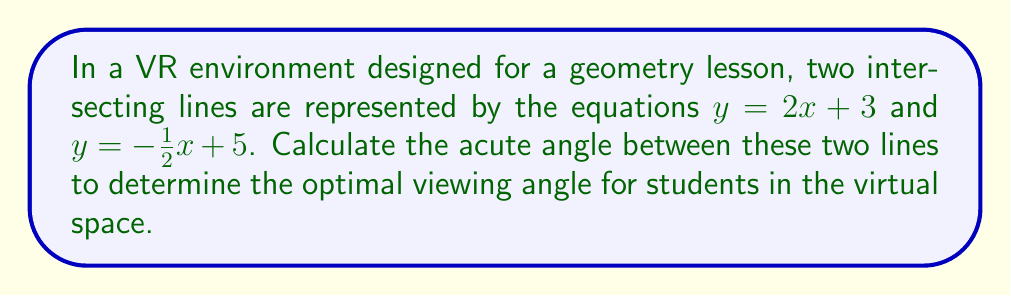What is the answer to this math problem? To find the angle between two intersecting lines in a VR environment, we can use the following steps:

1. Calculate the slopes of both lines:
   Line 1: $y = 2x + 3$, so $m_1 = 2$
   Line 2: $y = -\frac{1}{2}x + 5$, so $m_2 = -\frac{1}{2}$

2. Use the formula for the angle between two lines:
   $$\tan \theta = \left|\frac{m_1 - m_2}{1 + m_1m_2}\right|$$

3. Substitute the slopes into the formula:
   $$\tan \theta = \left|\frac{2 - (-\frac{1}{2})}{1 + 2(-\frac{1}{2})}\right| = \left|\frac{2 + \frac{1}{2}}{1 - 1}\right| = \left|\frac{\frac{5}{2}}{0}\right|$$

4. Simplify:
   $$\tan \theta = \frac{5}{2} = 2.5$$

5. To find $\theta$, we need to use the inverse tangent function:
   $$\theta = \arctan(2.5)$$

6. Using a calculator or computer, we can find:
   $$\theta \approx 1.1903 \text{ radians}$$

7. Convert radians to degrees:
   $$\theta \approx 1.1903 \times \frac{180}{\pi} \approx 68.20°$$

Therefore, the acute angle between the two lines in the VR environment is approximately 68.20°.
Answer: The acute angle between the two lines is approximately 68.20°. 